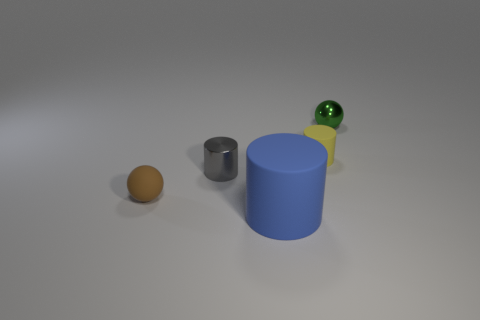How many tiny objects are either red balls or blue cylinders?
Provide a succinct answer. 0. There is a small rubber object that is in front of the metal object to the left of the metallic object to the right of the blue rubber object; what color is it?
Offer a very short reply. Brown. What number of other objects are there of the same color as the matte ball?
Offer a very short reply. 0. What number of matte things are blue cylinders or brown spheres?
Provide a succinct answer. 2. There is a yellow thing that is the same shape as the small gray metal thing; what is its size?
Make the answer very short. Small. Are there more big things that are in front of the brown rubber thing than red matte balls?
Your response must be concise. Yes. Are the tiny sphere behind the rubber ball and the tiny gray cylinder made of the same material?
Make the answer very short. Yes. What is the size of the rubber object that is behind the shiny object that is left of the sphere behind the gray object?
Ensure brevity in your answer.  Small. There is a gray cylinder that is the same material as the tiny green sphere; what size is it?
Give a very brief answer. Small. What is the color of the rubber object that is behind the big thing and in front of the small yellow cylinder?
Your answer should be very brief. Brown. 